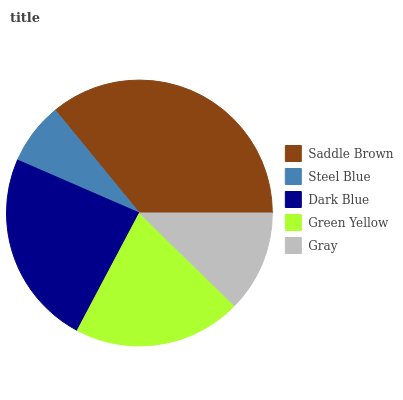Is Steel Blue the minimum?
Answer yes or no. Yes. Is Saddle Brown the maximum?
Answer yes or no. Yes. Is Dark Blue the minimum?
Answer yes or no. No. Is Dark Blue the maximum?
Answer yes or no. No. Is Dark Blue greater than Steel Blue?
Answer yes or no. Yes. Is Steel Blue less than Dark Blue?
Answer yes or no. Yes. Is Steel Blue greater than Dark Blue?
Answer yes or no. No. Is Dark Blue less than Steel Blue?
Answer yes or no. No. Is Green Yellow the high median?
Answer yes or no. Yes. Is Green Yellow the low median?
Answer yes or no. Yes. Is Saddle Brown the high median?
Answer yes or no. No. Is Dark Blue the low median?
Answer yes or no. No. 